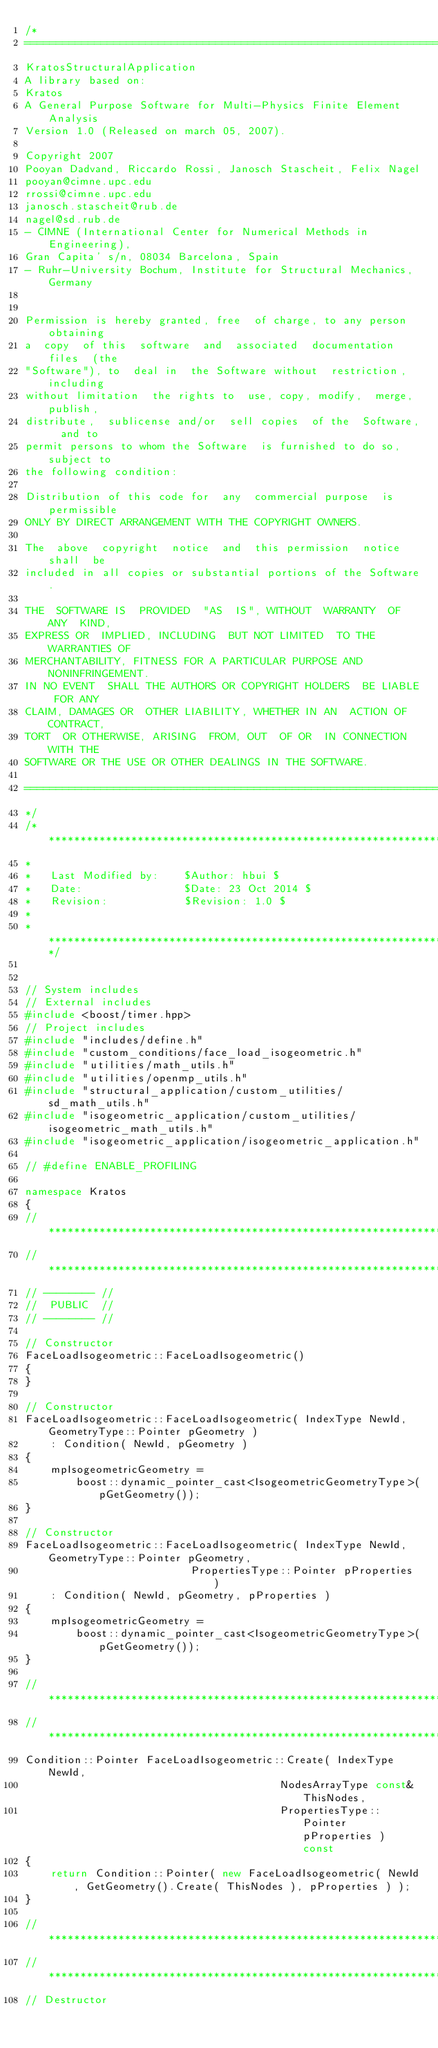<code> <loc_0><loc_0><loc_500><loc_500><_C++_>/*
==============================================================================
KratosStructuralApplication
A library based on:
Kratos
A General Purpose Software for Multi-Physics Finite Element Analysis
Version 1.0 (Released on march 05, 2007).

Copyright 2007
Pooyan Dadvand, Riccardo Rossi, Janosch Stascheit, Felix Nagel
pooyan@cimne.upc.edu
rrossi@cimne.upc.edu
janosch.stascheit@rub.de
nagel@sd.rub.de
- CIMNE (International Center for Numerical Methods in Engineering),
Gran Capita' s/n, 08034 Barcelona, Spain
- Ruhr-University Bochum, Institute for Structural Mechanics, Germany


Permission is hereby granted, free  of charge, to any person obtaining
a  copy  of this  software  and  associated  documentation files  (the
"Software"), to  deal in  the Software without  restriction, including
without limitation  the rights to  use, copy, modify,  merge, publish,
distribute,  sublicense and/or  sell copies  of the  Software,  and to
permit persons to whom the Software  is furnished to do so, subject to
the following condition:

Distribution of this code for  any  commercial purpose  is permissible
ONLY BY DIRECT ARRANGEMENT WITH THE COPYRIGHT OWNERS.

The  above  copyright  notice  and  this permission  notice  shall  be
included in all copies or substantial portions of the Software.

THE  SOFTWARE IS  PROVIDED  "AS  IS", WITHOUT  WARRANTY  OF ANY  KIND,
EXPRESS OR  IMPLIED, INCLUDING  BUT NOT LIMITED  TO THE  WARRANTIES OF
MERCHANTABILITY, FITNESS FOR A PARTICULAR PURPOSE AND NONINFRINGEMENT.
IN NO EVENT  SHALL THE AUTHORS OR COPYRIGHT HOLDERS  BE LIABLE FOR ANY
CLAIM, DAMAGES OR  OTHER LIABILITY, WHETHER IN AN  ACTION OF CONTRACT,
TORT  OR OTHERWISE, ARISING  FROM, OUT  OF OR  IN CONNECTION  WITH THE
SOFTWARE OR THE USE OR OTHER DEALINGS IN THE SOFTWARE.

==============================================================================
*/
/* **************************************************************************************
*
*   Last Modified by:    $Author: hbui $
*   Date:                $Date: 23 Oct 2014 $
*   Revision:            $Revision: 1.0 $
*
* ***************************************************************************************/


// System includes
// External includes
#include <boost/timer.hpp>
// Project includes
#include "includes/define.h"
#include "custom_conditions/face_load_isogeometric.h"
#include "utilities/math_utils.h"
#include "utilities/openmp_utils.h"
#include "structural_application/custom_utilities/sd_math_utils.h"
#include "isogeometric_application/custom_utilities/isogeometric_math_utils.h"
#include "isogeometric_application/isogeometric_application.h"

// #define ENABLE_PROFILING

namespace Kratos
{
//***********************************************************************************
//***********************************************************************************
// -------- //
//  PUBLIC  //
// -------- //

// Constructor
FaceLoadIsogeometric::FaceLoadIsogeometric()
{
}

// Constructor
FaceLoadIsogeometric::FaceLoadIsogeometric( IndexType NewId, GeometryType::Pointer pGeometry )
    : Condition( NewId, pGeometry )
{
    mpIsogeometricGeometry =
        boost::dynamic_pointer_cast<IsogeometricGeometryType>(pGetGeometry());
}

// Constructor
FaceLoadIsogeometric::FaceLoadIsogeometric( IndexType NewId, GeometryType::Pointer pGeometry,
                          PropertiesType::Pointer pProperties )
    : Condition( NewId, pGeometry, pProperties )
{
    mpIsogeometricGeometry =
        boost::dynamic_pointer_cast<IsogeometricGeometryType>(pGetGeometry());
}

//***********************************************************************************
//***********************************************************************************
Condition::Pointer FaceLoadIsogeometric::Create( IndexType NewId,
                                        NodesArrayType const& ThisNodes,
                                        PropertiesType::Pointer pProperties ) const
{
    return Condition::Pointer( new FaceLoadIsogeometric( NewId, GetGeometry().Create( ThisNodes ), pProperties ) );
}

//***********************************************************************************
//***********************************************************************************
// Destructor</code> 